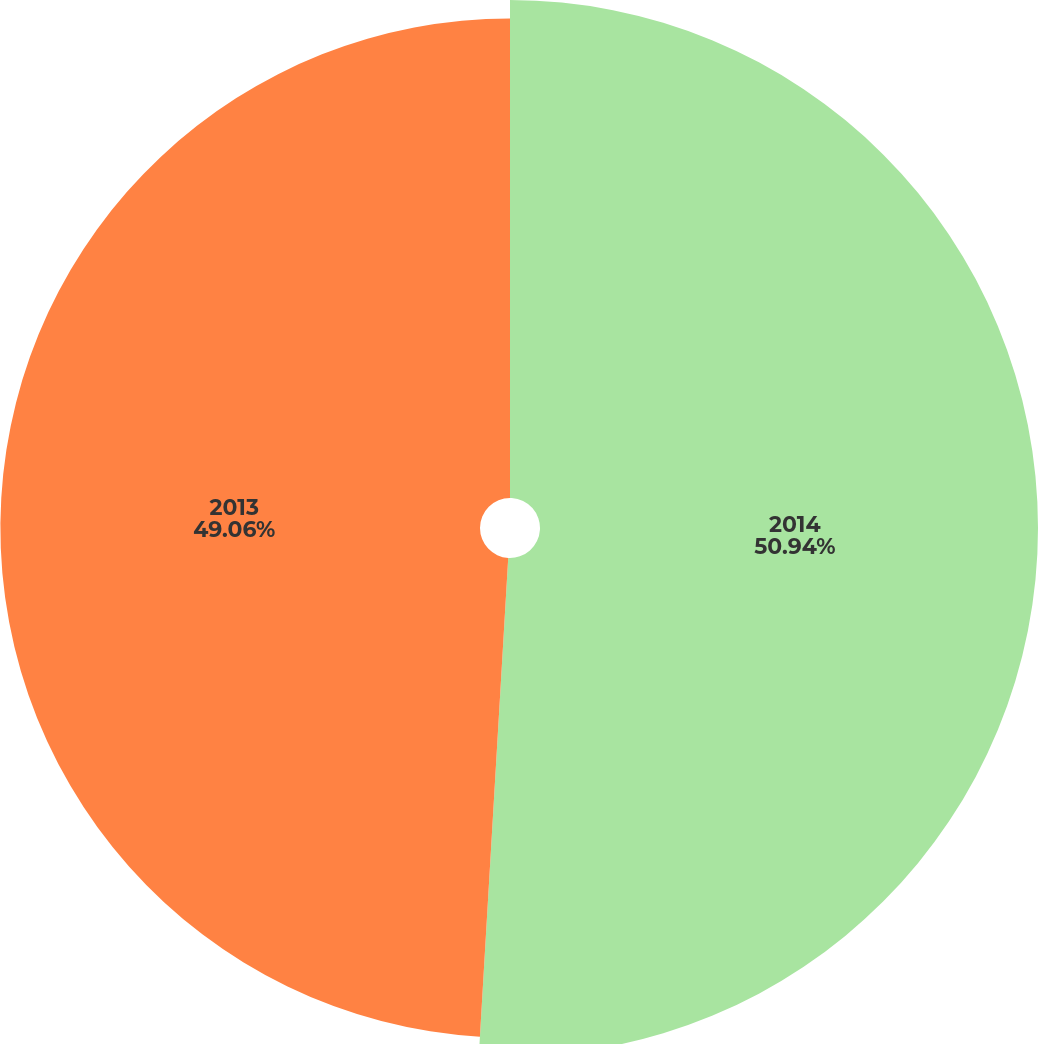Convert chart. <chart><loc_0><loc_0><loc_500><loc_500><pie_chart><fcel>2014<fcel>2013<nl><fcel>50.94%<fcel>49.06%<nl></chart> 